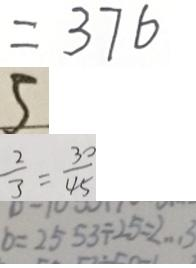Convert formula to latex. <formula><loc_0><loc_0><loc_500><loc_500>= 3 7 6 
 5 
 \frac { 2 } { 3 } = \frac { 3 0 } { 4 5 } 
 b = 2 5 5 3 \div 2 5 = 2 \cdots 3</formula> 